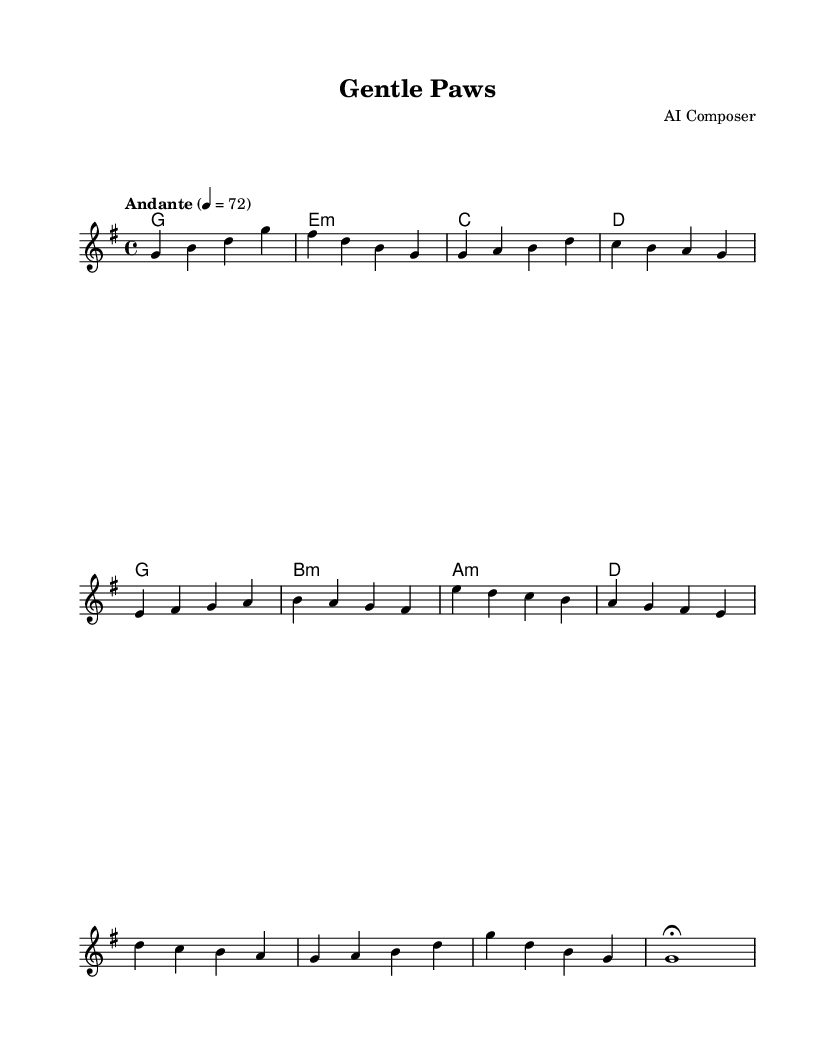What is the key signature of this music? The key signature is G major, indicated by one sharp (F#) which is shown at the beginning of the staff.
Answer: G major What is the time signature of this piece? The time signature is 4/4, as noted at the beginning of the score, which indicates that there are four beats per measure.
Answer: 4/4 What tempo marking is indicated in this score? The tempo marking is "Andante," which suggests a moderate walking pace for the music, noted at the start of the score with a metronome marking of 72 beats per minute.
Answer: Andante How many measures are there in the melody section? The melody section consists of 12 measures in total; counted from the beginning to the end of the provided melody line in the score.
Answer: 12 measures What is the last note of the melody? The last note of the melody is G, indicated in the final measure of the score, with a fermata which instructs to hold the note longer than its usual duration.
Answer: G What are the first three chords indicated in this score? The first three chords are G major, E minor, and C major, as these are shown at the beginning of the chord section beneath the melody line.
Answer: G, E minor, C What section of the music ends with a fermata? The music's last section, referred to as the "Outro," concludes with a fermata, which signifies that the last note can be extended in duration for expressive effect.
Answer: Outro 